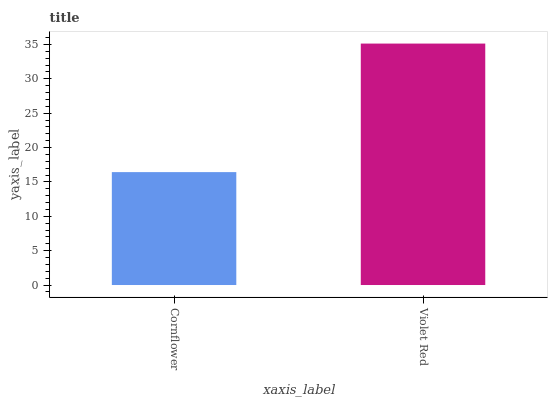Is Cornflower the minimum?
Answer yes or no. Yes. Is Violet Red the maximum?
Answer yes or no. Yes. Is Violet Red the minimum?
Answer yes or no. No. Is Violet Red greater than Cornflower?
Answer yes or no. Yes. Is Cornflower less than Violet Red?
Answer yes or no. Yes. Is Cornflower greater than Violet Red?
Answer yes or no. No. Is Violet Red less than Cornflower?
Answer yes or no. No. Is Violet Red the high median?
Answer yes or no. Yes. Is Cornflower the low median?
Answer yes or no. Yes. Is Cornflower the high median?
Answer yes or no. No. Is Violet Red the low median?
Answer yes or no. No. 